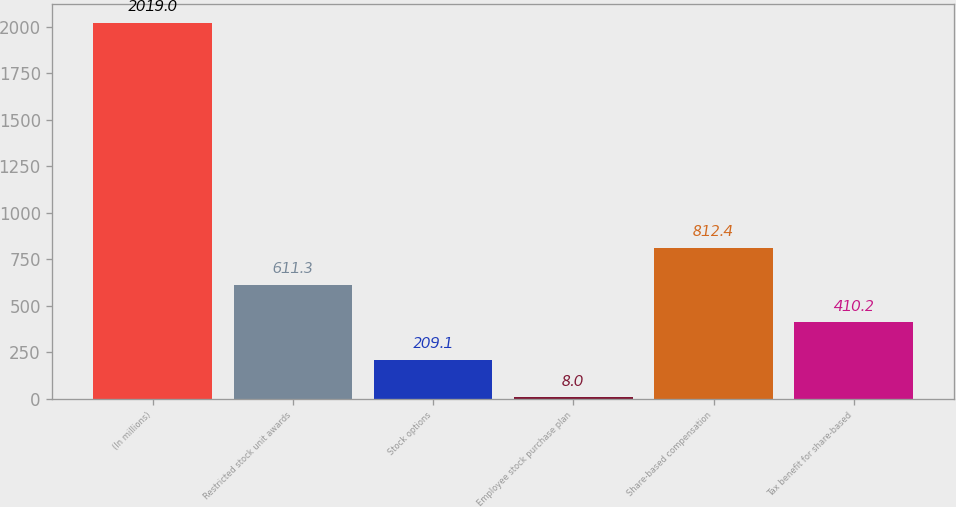Convert chart. <chart><loc_0><loc_0><loc_500><loc_500><bar_chart><fcel>(In millions)<fcel>Restricted stock unit awards<fcel>Stock options<fcel>Employee stock purchase plan<fcel>Share-based compensation<fcel>Tax benefit for share-based<nl><fcel>2019<fcel>611.3<fcel>209.1<fcel>8<fcel>812.4<fcel>410.2<nl></chart> 